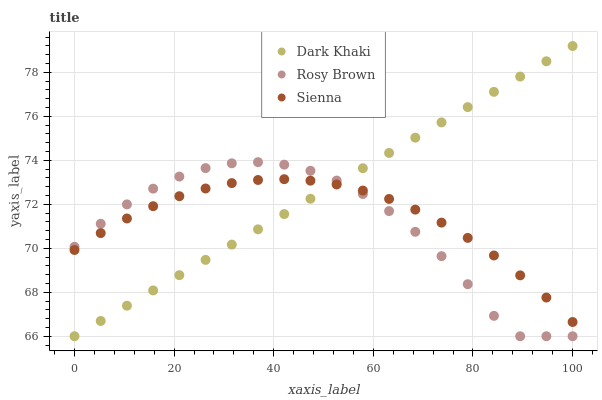Does Rosy Brown have the minimum area under the curve?
Answer yes or no. Yes. Does Dark Khaki have the maximum area under the curve?
Answer yes or no. Yes. Does Sienna have the minimum area under the curve?
Answer yes or no. No. Does Sienna have the maximum area under the curve?
Answer yes or no. No. Is Dark Khaki the smoothest?
Answer yes or no. Yes. Is Rosy Brown the roughest?
Answer yes or no. Yes. Is Sienna the smoothest?
Answer yes or no. No. Is Sienna the roughest?
Answer yes or no. No. Does Dark Khaki have the lowest value?
Answer yes or no. Yes. Does Sienna have the lowest value?
Answer yes or no. No. Does Dark Khaki have the highest value?
Answer yes or no. Yes. Does Rosy Brown have the highest value?
Answer yes or no. No. Does Dark Khaki intersect Rosy Brown?
Answer yes or no. Yes. Is Dark Khaki less than Rosy Brown?
Answer yes or no. No. Is Dark Khaki greater than Rosy Brown?
Answer yes or no. No. 